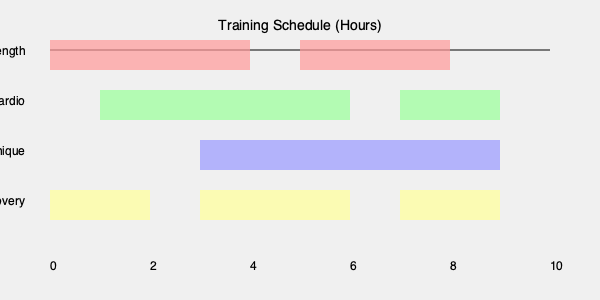Based on the training schedule diagram, which 2-hour time slot would be most efficient for maximizing training across different areas with minimal overlap? To find the most efficient 2-hour time slot, we need to analyze the diagram and look for a period where we can cover the most training areas with the least overlap. Let's break it down step-by-step:

1. Examine the 0-2 hour slot:
   - Covers Strength and Recovery
   - 2 areas, no overlap

2. Examine the 2-4 hour slot:
   - Covers Strength, Cardio, and Recovery
   - 3 areas, some overlap

3. Examine the 4-6 hour slot:
   - Covers Cardio and Technique
   - 2 areas, no overlap

4. Examine the 6-8 hour slot:
   - Covers Cardio, Technique, and Recovery
   - 3 areas, some overlap

5. Examine the 8-10 hour slot:
   - Covers Strength, Technique, and Recovery
   - 3 areas, some overlap

The most efficient slot would be the one that covers the most training areas with the least overlap. In this case, the 6-8 hour slot is optimal because:
- It covers 3 different training areas (Cardio, Technique, and Recovery)
- The overlap is minimal compared to other slots covering 3 areas
- It allows for a balanced combination of cardiovascular fitness, technical skills, and recovery time
Answer: 6-8 hour slot 